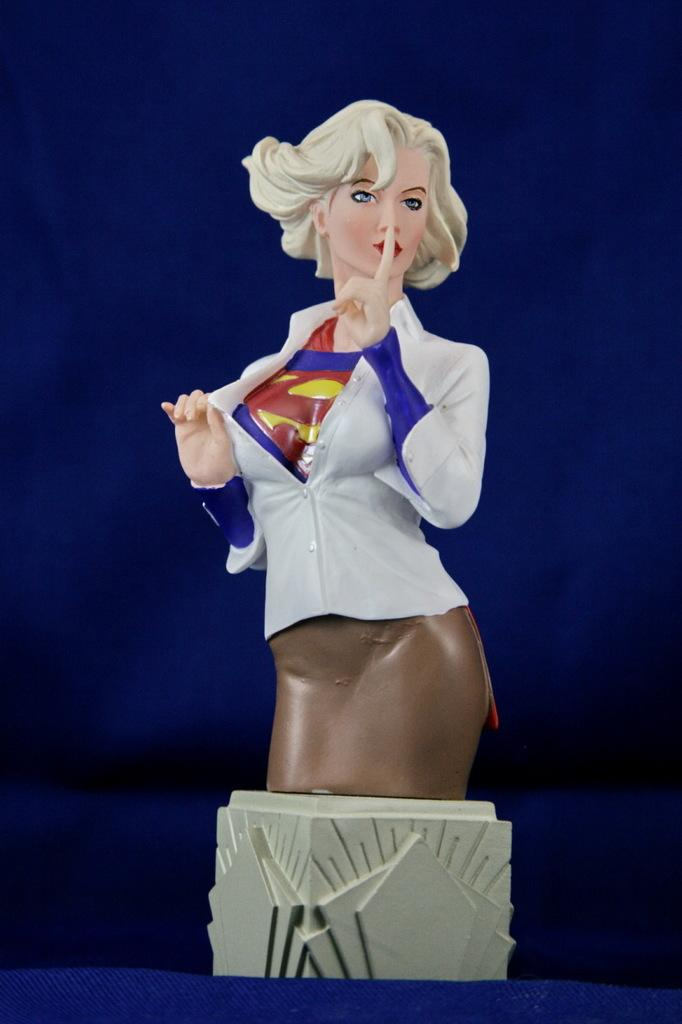What type of object is depicted in the image? There is a toy of a woman in the picture. What is the toy placed on? The toy is placed on an object. What color is the background of the image? The background of the image is blue. Where is the faucet located in the image? There is no faucet present in the image. What is the toy's daughter doing in the image? The toy does not have a daughter, as it is a toy and not a real person. 